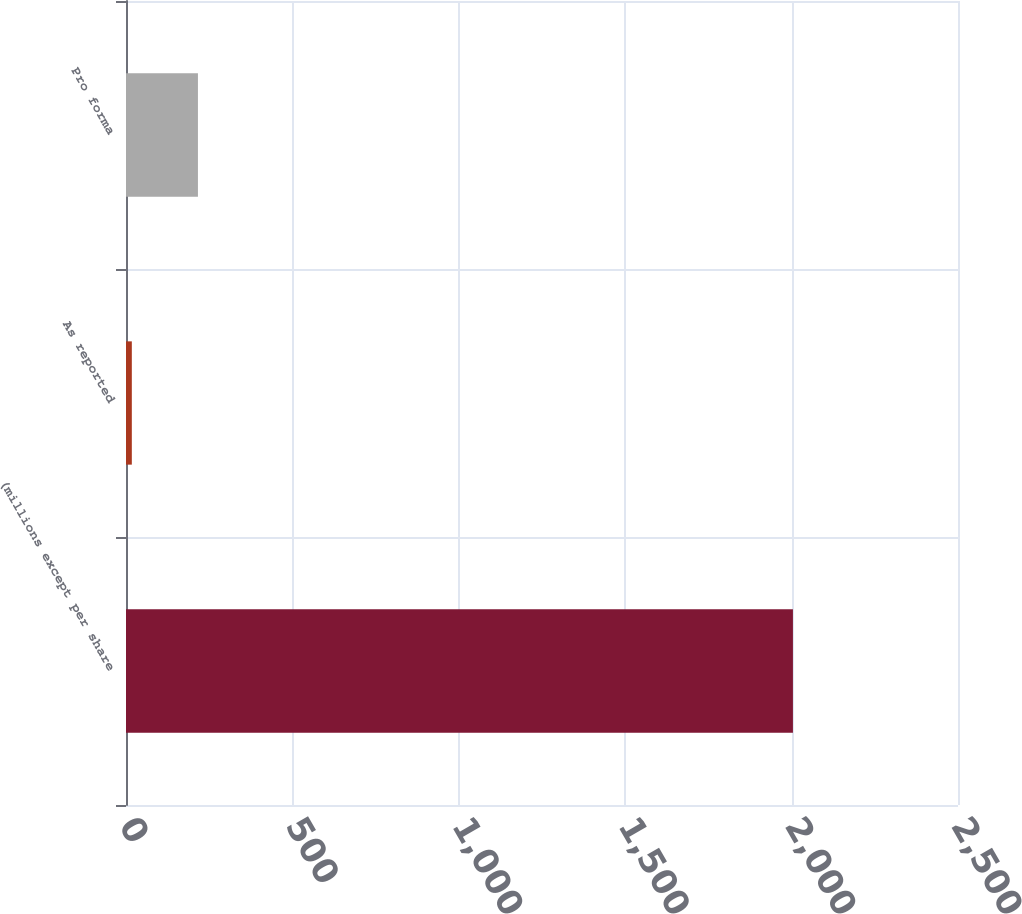Convert chart to OTSL. <chart><loc_0><loc_0><loc_500><loc_500><bar_chart><fcel>(millions except per share<fcel>As reported<fcel>Pro forma<nl><fcel>2004<fcel>17.5<fcel>216.15<nl></chart> 